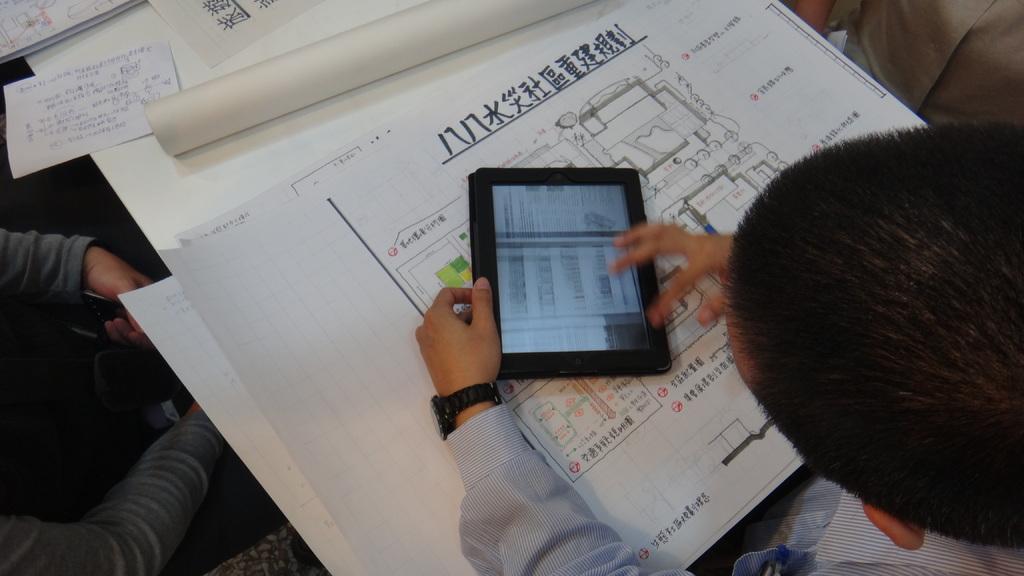How would you summarize this image in a sentence or two? In this image we can see a person using a ipad. There is a table on which there are charts. To the left side of the image there is a person. 